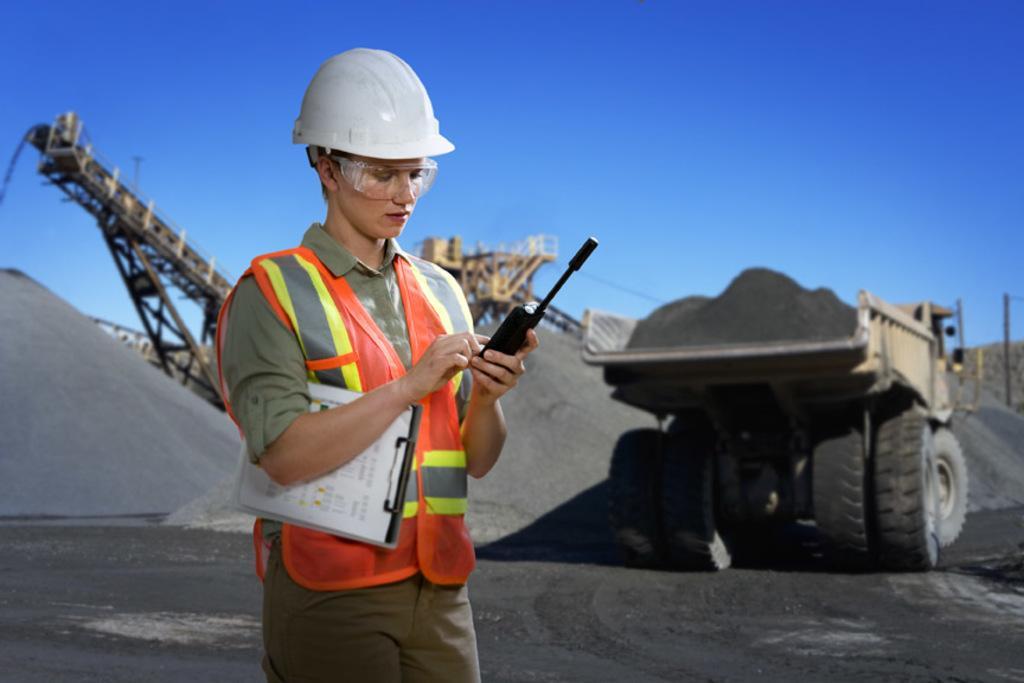Please provide a concise description of this image. This is the picture of a person who is wearing the helmet and holding a microphone and to the side there is a vehicle and some sand on the floor. 